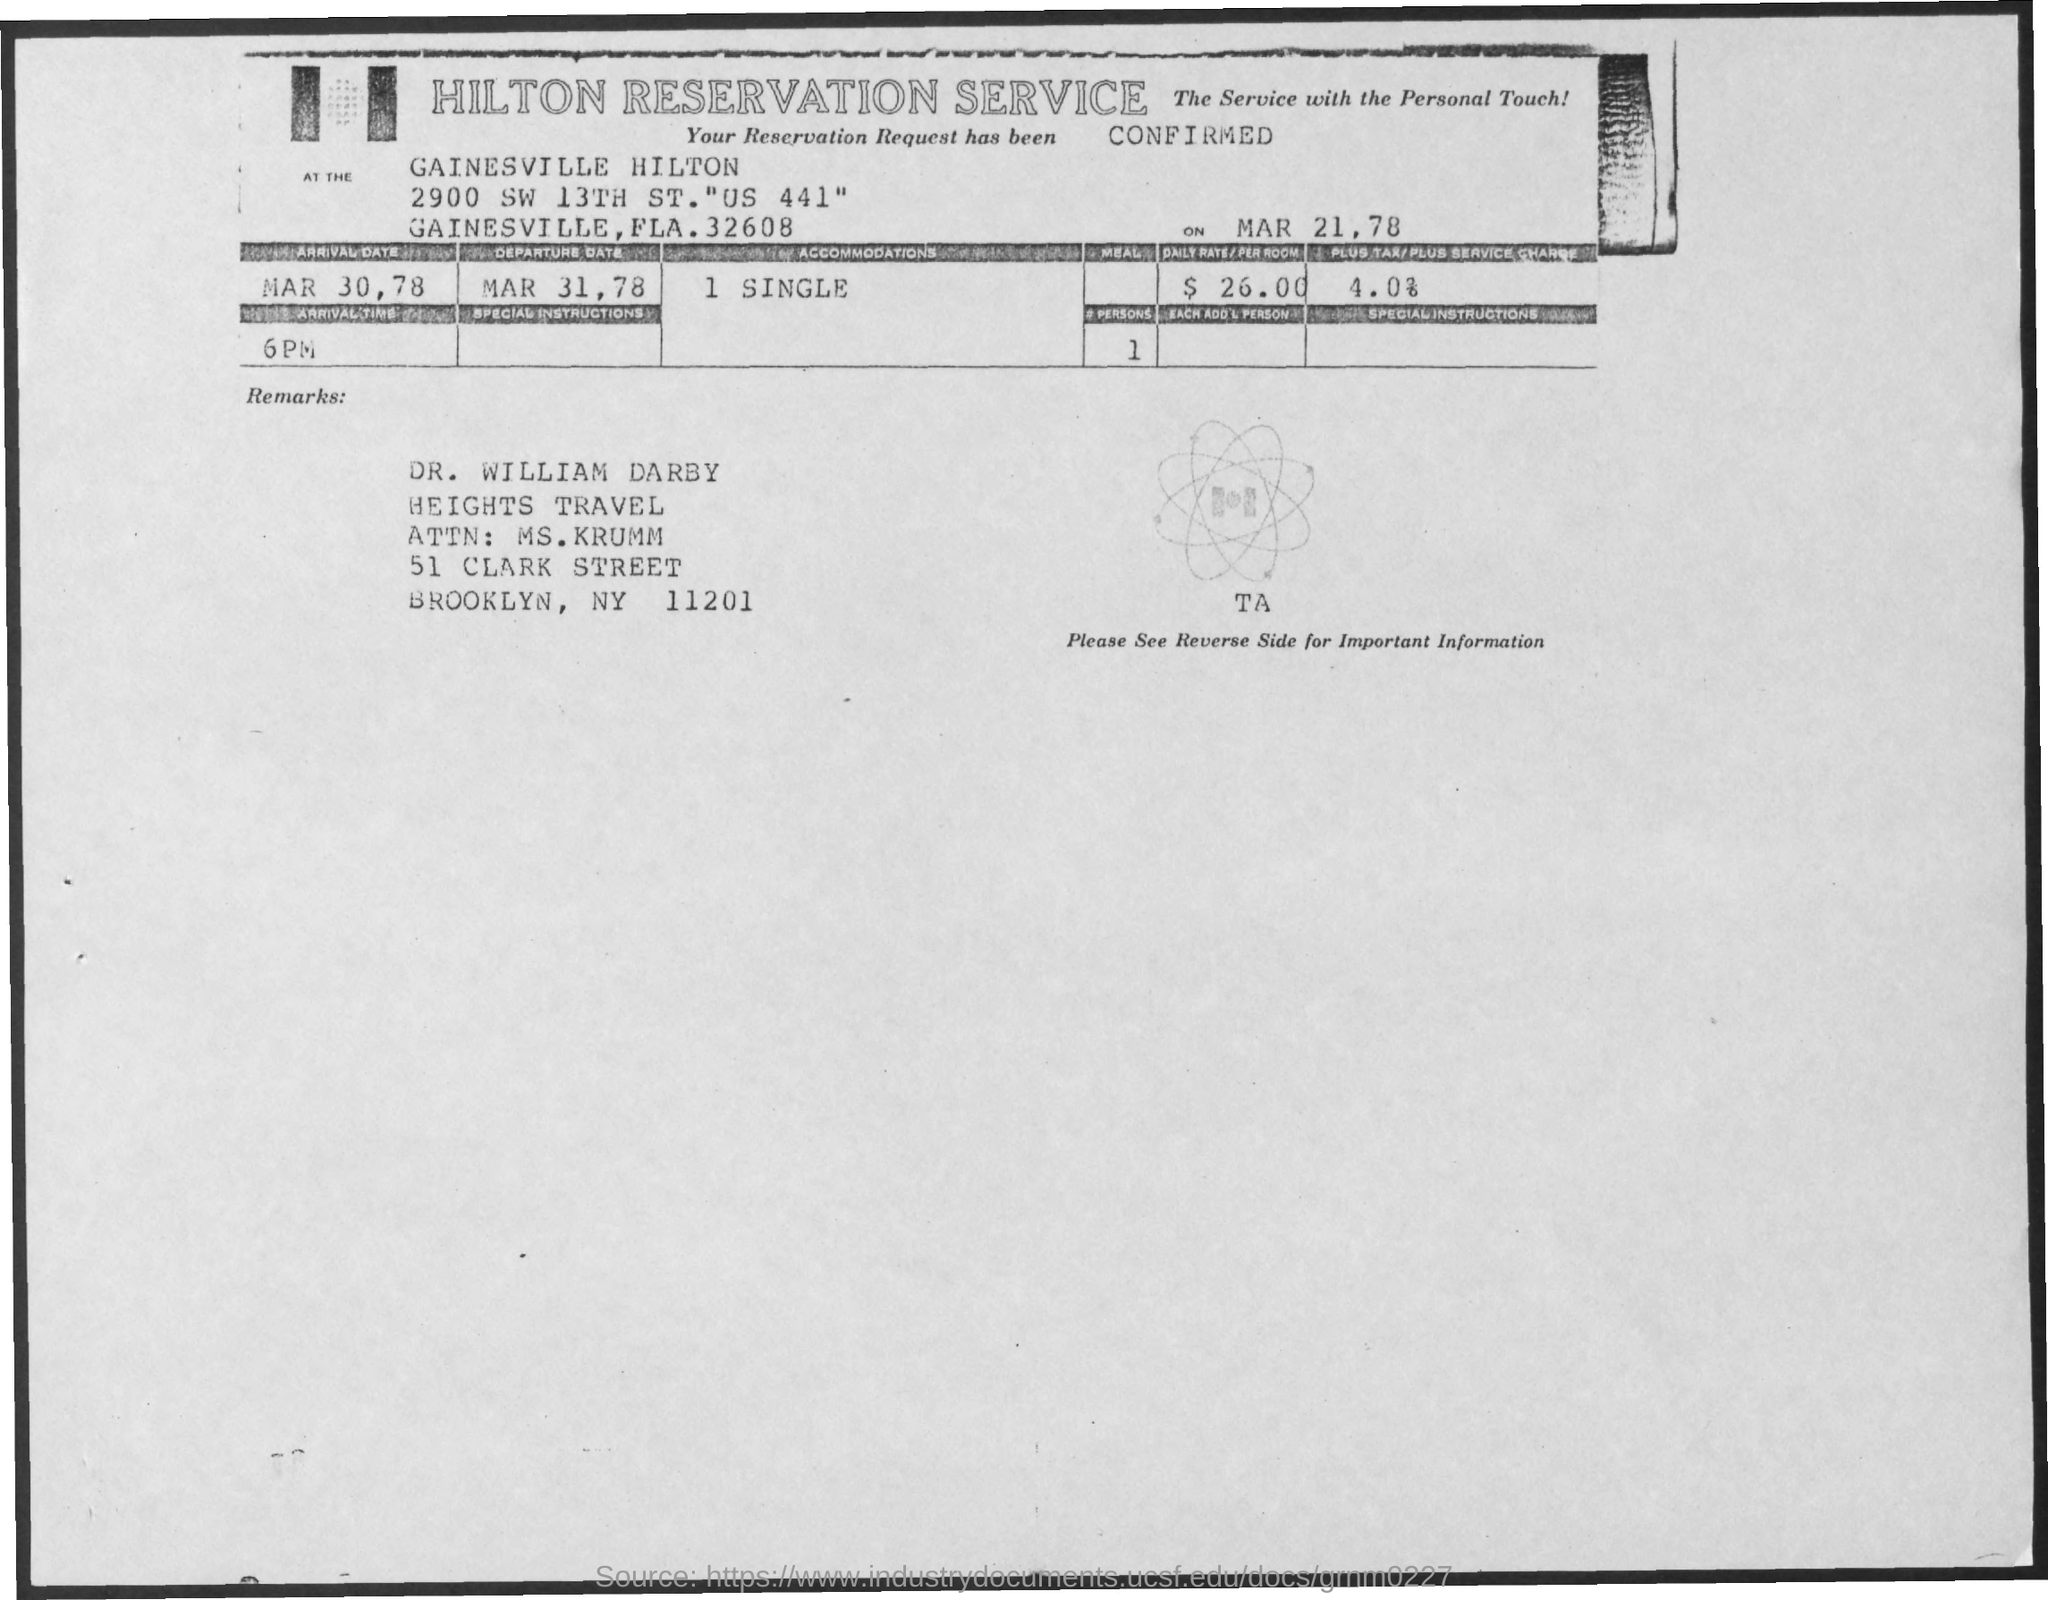List a handful of essential elements in this visual. The main title of the document is 'Hilton Reservation Service.' 